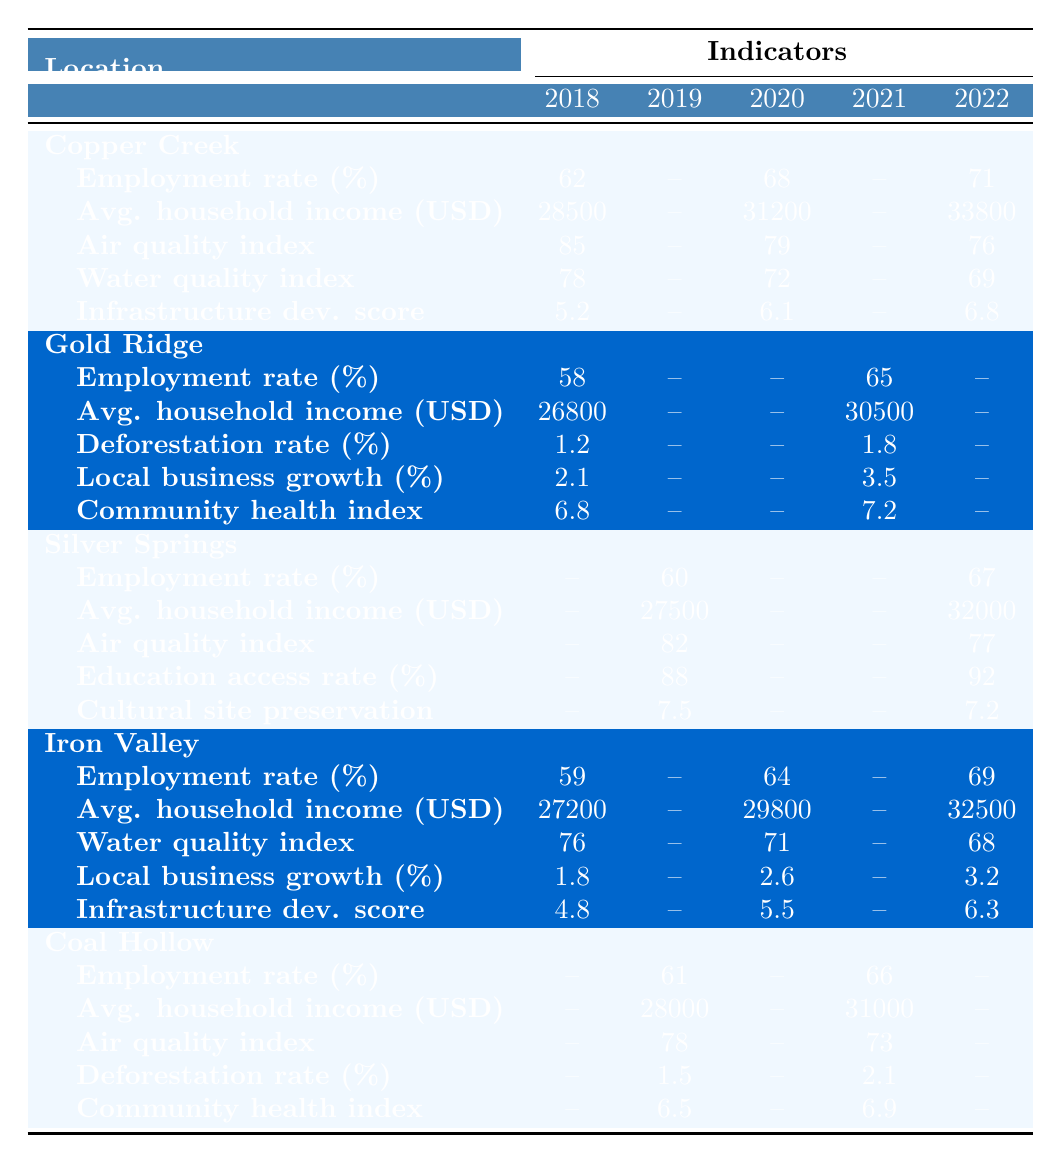What was the employment rate in Copper Creek in 2022? The table shows that the employment rate in Copper Creek in 2022 is 71%.
Answer: 71% What is the average household income in Gold Ridge in 2021? The average household income in Gold Ridge for the year 2021 is 30,500 USD, as per the table.
Answer: 30,500 USD Which location had the highest average household income in 2022? In 2022, Copper Creek had the highest average household income of 33,800 USD compared to other locations.
Answer: Copper Creek What was the air quality index change in Copper Creek from 2018 to 2022? The air quality index in Copper Creek decreased from 85 in 2018 to 76 in 2022, resulting in a change of -9.
Answer: -9 Did Silver Springs see an increase in the employment rate from 2019 to 2022? Yes, the employment rate in Silver Springs increased from 60% in 2019 to 67% in 2022.
Answer: Yes Which location had the lowest water quality index in 2022? In 2022, Iron Valley had the lowest water quality index at 68, making it the lowest in that year among the listed locations.
Answer: Iron Valley Calculate the average employment rate in Iron Valley from 2018 to 2022. The employment rates for Iron Valley are 59% (2018), 64% (2020), and 69% (2022). The average is (59 + 64 + 69) / 3 = 64%.
Answer: 64% Is the community health index in Gold Ridge higher in 2021 than in previous years? Yes, the community health index in Gold Ridge in 2021 is 7.2, which is higher than 6.8 in 2018.
Answer: Yes What is the trend in local business growth in Iron Valley from 2018 to 2022? Local business growth in Iron Valley increased from 1.8% in 2018 to 3.2% in 2022, indicating a positive trend.
Answer: Positive trend Did Copper Creek have an increase in the infrastructure development score from 2018 to 2022? Yes, the infrastructure development score in Copper Creek rose from 5.2 in 2018 to 6.8 in 2022.
Answer: Yes 